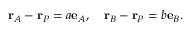<formula> <loc_0><loc_0><loc_500><loc_500>r _ { A } - r _ { P } = a e _ { A } , \quad r _ { B } - r _ { P } = b e _ { B } .</formula> 